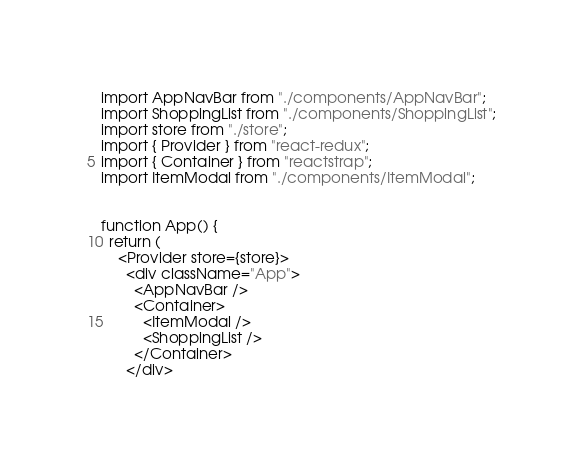Convert code to text. <code><loc_0><loc_0><loc_500><loc_500><_JavaScript_>import AppNavBar from "./components/AppNavBar";
import ShoppingList from "./components/ShoppingList";
import store from "./store";
import { Provider } from "react-redux";
import { Container } from "reactstrap";
import ItemModal from "./components/ItemModal";


function App() {
  return (
    <Provider store={store}>
      <div className="App">
        <AppNavBar />
        <Container>
          <ItemModal />
          <ShoppingList />
        </Container>
      </div></code> 